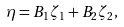<formula> <loc_0><loc_0><loc_500><loc_500>\eta = B _ { 1 } \zeta _ { 1 } + B _ { 2 } \zeta _ { 2 } ,</formula> 